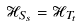Convert formula to latex. <formula><loc_0><loc_0><loc_500><loc_500>\mathcal { H } _ { S _ { s } } = \mathcal { H } _ { T _ { t } }</formula> 